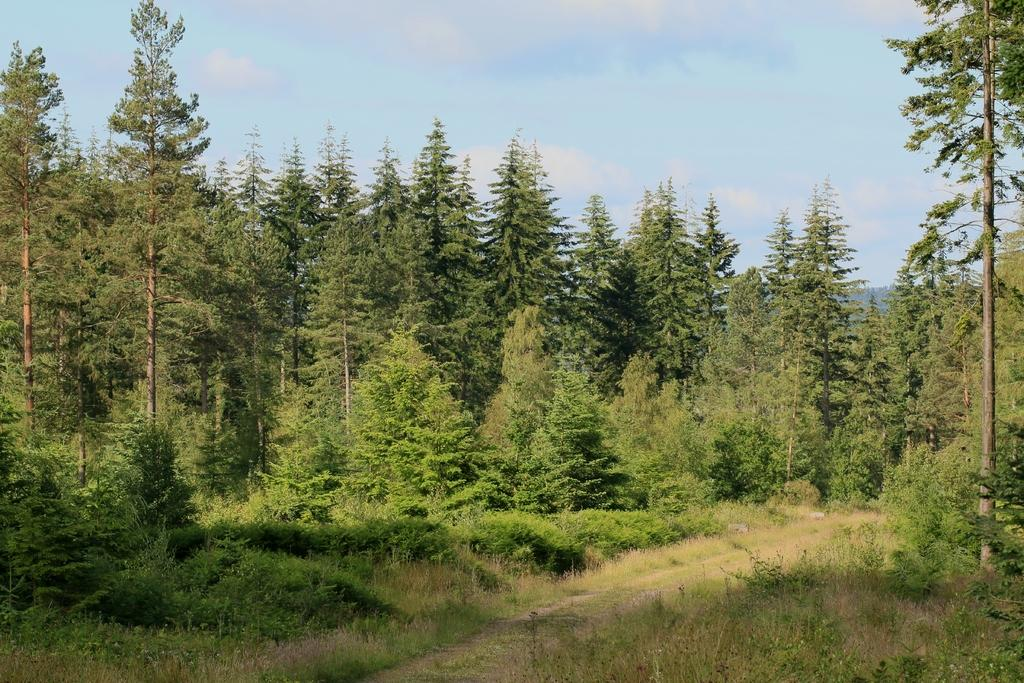What type of natural environment is depicted in the image? There is a forest area in the image. What specific features can be seen in the forest? There are trees and grass visible in the image. What is visible at the top of the image? The sky is visible at the top of the image. Reasoning: Let'g: Let's think step by step in order to produce the conversation. We start by identifying the main subject of the image, which is the forest area. Then, we describe specific features of the forest, such as the trees and grass. Finally, we mention the sky's visibility to give a sense of the weather or time of day. Absurd Question/Answer: Can you tell me how many sheets are hanging on the trees in the image? There are no sheets present in the image; it features a forest area with trees and grass. What type of creature is shown interacting with the mist in the image? There is no mist or creature shown interacting with it in the image. 